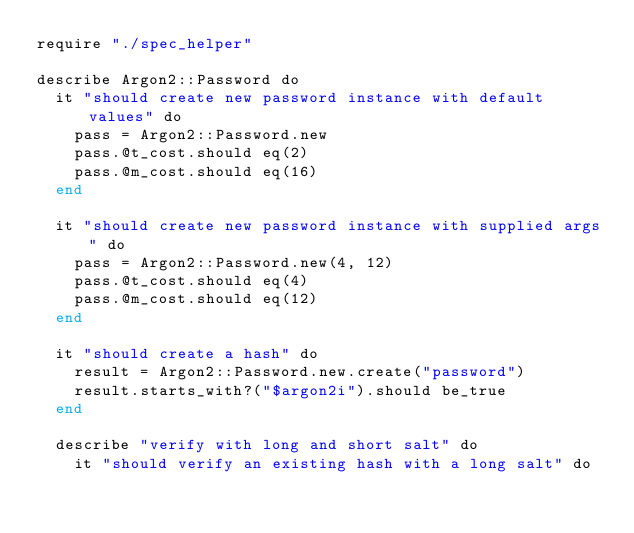Convert code to text. <code><loc_0><loc_0><loc_500><loc_500><_Crystal_>require "./spec_helper"

describe Argon2::Password do
  it "should create new password instance with default values" do
    pass = Argon2::Password.new
    pass.@t_cost.should eq(2)
    pass.@m_cost.should eq(16)
  end

  it "should create new password instance with supplied args" do
    pass = Argon2::Password.new(4, 12)
    pass.@t_cost.should eq(4)
    pass.@m_cost.should eq(12)
  end

  it "should create a hash" do
    result = Argon2::Password.new.create("password")
    result.starts_with?("$argon2i").should be_true
  end

  describe "verify with long and short salt" do
    it "should verify an existing hash with a long salt" do</code> 